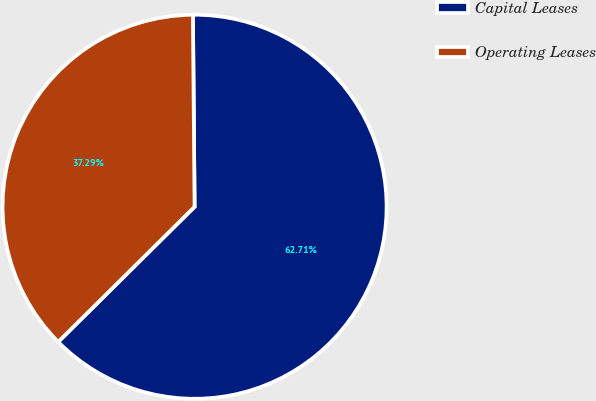<chart> <loc_0><loc_0><loc_500><loc_500><pie_chart><fcel>Capital Leases<fcel>Operating Leases<nl><fcel>62.71%<fcel>37.29%<nl></chart> 